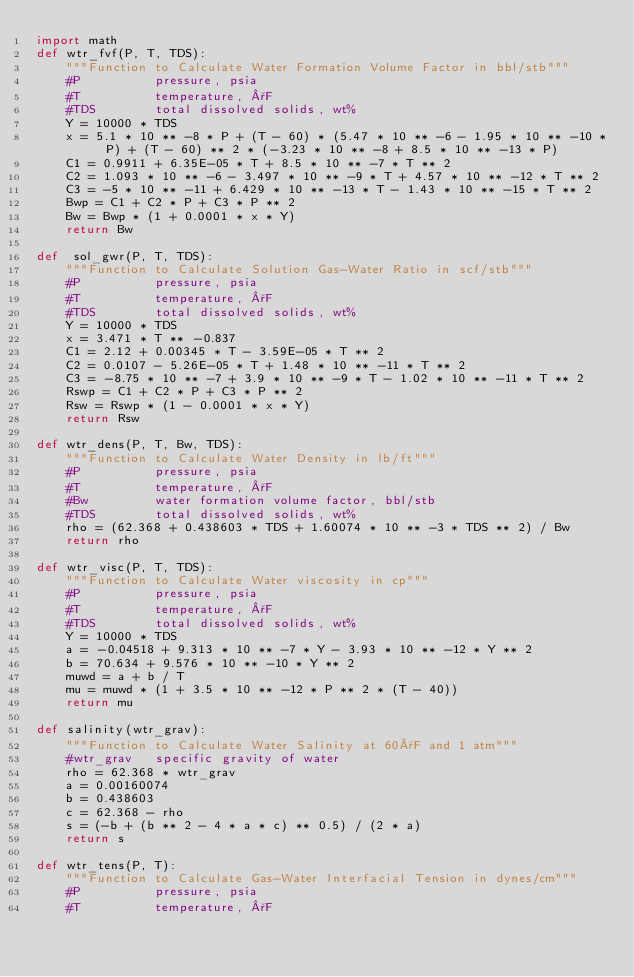Convert code to text. <code><loc_0><loc_0><loc_500><loc_500><_Python_>import math
def wtr_fvf(P, T, TDS):
    """Function to Calculate Water Formation Volume Factor in bbl/stb"""
    #P          pressure, psia
    #T          temperature, °F
    #TDS        total dissolved solids, wt%
    Y = 10000 * TDS
    x = 5.1 * 10 ** -8 * P + (T - 60) * (5.47 * 10 ** -6 - 1.95 * 10 ** -10 * P) + (T - 60) ** 2 * (-3.23 * 10 ** -8 + 8.5 * 10 ** -13 * P)
    C1 = 0.9911 + 6.35E-05 * T + 8.5 * 10 ** -7 * T ** 2
    C2 = 1.093 * 10 ** -6 - 3.497 * 10 ** -9 * T + 4.57 * 10 ** -12 * T ** 2
    C3 = -5 * 10 ** -11 + 6.429 * 10 ** -13 * T - 1.43 * 10 ** -15 * T ** 2
    Bwp = C1 + C2 * P + C3 * P ** 2
    Bw = Bwp * (1 + 0.0001 * x * Y)
    return Bw

def  sol_gwr(P, T, TDS):
    """Function to Calculate Solution Gas-Water Ratio in scf/stb"""
    #P          pressure, psia
    #T          temperature, °F
    #TDS        total dissolved solids, wt%
    Y = 10000 * TDS
    x = 3.471 * T ** -0.837
    C1 = 2.12 + 0.00345 * T - 3.59E-05 * T ** 2
    C2 = 0.0107 - 5.26E-05 * T + 1.48 * 10 ** -11 * T ** 2
    C3 = -8.75 * 10 ** -7 + 3.9 * 10 ** -9 * T - 1.02 * 10 ** -11 * T ** 2
    Rswp = C1 + C2 * P + C3 * P ** 2
    Rsw = Rswp * (1 - 0.0001 * x * Y)
    return Rsw

def wtr_dens(P, T, Bw, TDS):
    """Function to Calculate Water Density in lb/ft"""
    #P          pressure, psia
    #T          temperature, °F
    #Bw         water formation volume factor, bbl/stb
    #TDS        total dissolved solids, wt%
    rho = (62.368 + 0.438603 * TDS + 1.60074 * 10 ** -3 * TDS ** 2) / Bw
    return rho

def wtr_visc(P, T, TDS):
    """Function to Calculate Water viscosity in cp"""
    #P          pressure, psia
    #T          temperature, °F
    #TDS        total dissolved solids, wt%
    Y = 10000 * TDS
    a = -0.04518 + 9.313 * 10 ** -7 * Y - 3.93 * 10 ** -12 * Y ** 2
    b = 70.634 + 9.576 * 10 ** -10 * Y ** 2
    muwd = a + b / T
    mu = muwd * (1 + 3.5 * 10 ** -12 * P ** 2 * (T - 40))
    return mu

def salinity(wtr_grav):
    """Function to Calculate Water Salinity at 60°F and 1 atm"""
    #wtr_grav   specific gravity of water
    rho = 62.368 * wtr_grav
    a = 0.00160074
    b = 0.438603
    c = 62.368 - rho
    s = (-b + (b ** 2 - 4 * a * c) ** 0.5) / (2 * a)
    return s

def wtr_tens(P, T):
    """Function to Calculate Gas-Water Interfacial Tension in dynes/cm"""
    #P          pressure, psia
    #T          temperature, °F</code> 